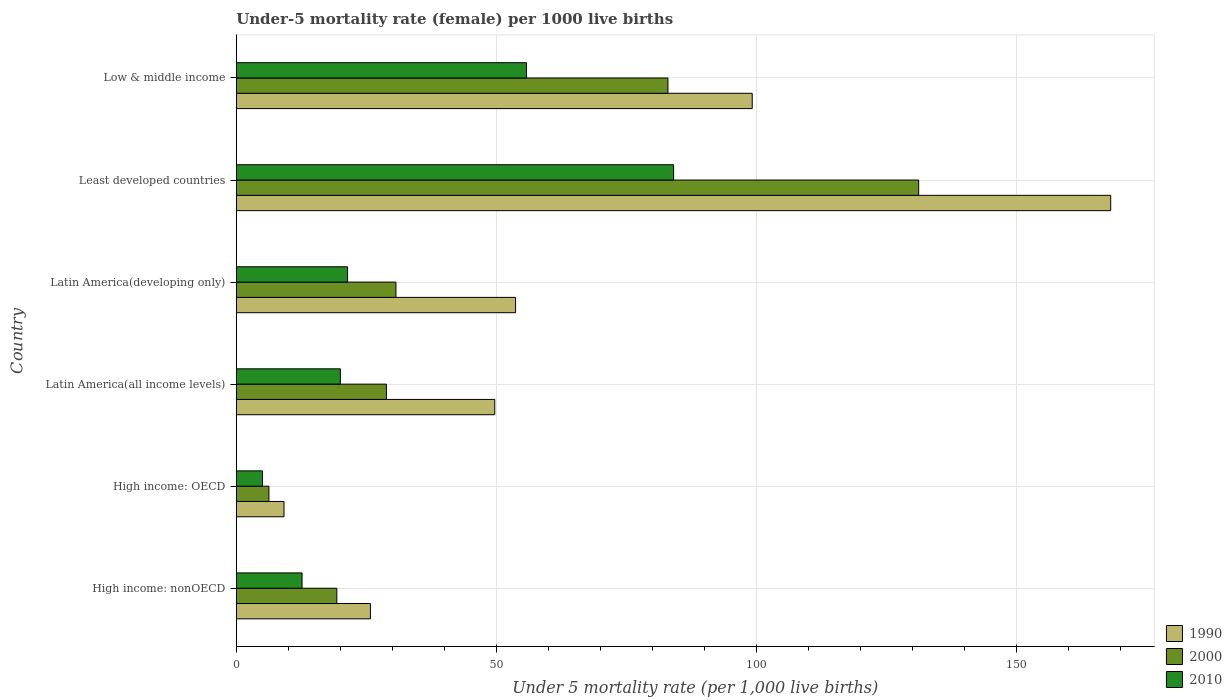How many different coloured bars are there?
Offer a terse response. 3. What is the label of the 6th group of bars from the top?
Give a very brief answer. High income: nonOECD. In how many cases, is the number of bars for a given country not equal to the number of legend labels?
Provide a succinct answer. 0. What is the under-five mortality rate in 1990 in Least developed countries?
Make the answer very short. 168.12. Across all countries, what is the maximum under-five mortality rate in 1990?
Provide a short and direct response. 168.12. Across all countries, what is the minimum under-five mortality rate in 1990?
Provide a short and direct response. 9.18. In which country was the under-five mortality rate in 2000 maximum?
Ensure brevity in your answer.  Least developed countries. In which country was the under-five mortality rate in 2000 minimum?
Provide a short and direct response. High income: OECD. What is the total under-five mortality rate in 2010 in the graph?
Make the answer very short. 198.99. What is the difference between the under-five mortality rate in 2010 in Latin America(developing only) and that in Least developed countries?
Keep it short and to the point. -62.69. What is the difference between the under-five mortality rate in 2000 in Latin America(all income levels) and the under-five mortality rate in 1990 in Least developed countries?
Provide a succinct answer. -139.26. What is the average under-five mortality rate in 2010 per country?
Your response must be concise. 33.17. What is the difference between the under-five mortality rate in 2010 and under-five mortality rate in 1990 in Low & middle income?
Provide a short and direct response. -43.4. What is the ratio of the under-five mortality rate in 2000 in Latin America(all income levels) to that in Low & middle income?
Offer a terse response. 0.35. What is the difference between the highest and the second highest under-five mortality rate in 1990?
Ensure brevity in your answer.  68.92. What is the difference between the highest and the lowest under-five mortality rate in 2000?
Your answer should be very brief. 124.92. In how many countries, is the under-five mortality rate in 2010 greater than the average under-five mortality rate in 2010 taken over all countries?
Your answer should be very brief. 2. Are all the bars in the graph horizontal?
Offer a very short reply. Yes. How many countries are there in the graph?
Offer a very short reply. 6. Are the values on the major ticks of X-axis written in scientific E-notation?
Provide a succinct answer. No. Does the graph contain any zero values?
Your answer should be very brief. No. Does the graph contain grids?
Your answer should be compact. Yes. What is the title of the graph?
Your answer should be compact. Under-5 mortality rate (female) per 1000 live births. What is the label or title of the X-axis?
Your response must be concise. Under 5 mortality rate (per 1,0 live births). What is the Under 5 mortality rate (per 1,000 live births) in 1990 in High income: nonOECD?
Make the answer very short. 25.8. What is the Under 5 mortality rate (per 1,000 live births) in 2000 in High income: nonOECD?
Offer a very short reply. 19.34. What is the Under 5 mortality rate (per 1,000 live births) in 2010 in High income: nonOECD?
Keep it short and to the point. 12.65. What is the Under 5 mortality rate (per 1,000 live births) in 1990 in High income: OECD?
Your response must be concise. 9.18. What is the Under 5 mortality rate (per 1,000 live births) in 2000 in High income: OECD?
Provide a succinct answer. 6.28. What is the Under 5 mortality rate (per 1,000 live births) of 2010 in High income: OECD?
Keep it short and to the point. 5.04. What is the Under 5 mortality rate (per 1,000 live births) of 1990 in Latin America(all income levels)?
Your answer should be compact. 49.7. What is the Under 5 mortality rate (per 1,000 live births) of 2000 in Latin America(all income levels)?
Ensure brevity in your answer.  28.87. What is the Under 5 mortality rate (per 1,000 live births) of 2010 in Latin America(all income levels)?
Ensure brevity in your answer.  20.02. What is the Under 5 mortality rate (per 1,000 live births) of 1990 in Latin America(developing only)?
Provide a succinct answer. 53.7. What is the Under 5 mortality rate (per 1,000 live births) of 2000 in Latin America(developing only)?
Offer a terse response. 30.7. What is the Under 5 mortality rate (per 1,000 live births) of 2010 in Latin America(developing only)?
Offer a terse response. 21.4. What is the Under 5 mortality rate (per 1,000 live births) of 1990 in Least developed countries?
Provide a short and direct response. 168.12. What is the Under 5 mortality rate (per 1,000 live births) in 2000 in Least developed countries?
Ensure brevity in your answer.  131.2. What is the Under 5 mortality rate (per 1,000 live births) of 2010 in Least developed countries?
Offer a terse response. 84.09. What is the Under 5 mortality rate (per 1,000 live births) in 1990 in Low & middle income?
Provide a succinct answer. 99.2. What is the Under 5 mortality rate (per 1,000 live births) of 2000 in Low & middle income?
Ensure brevity in your answer.  83. What is the Under 5 mortality rate (per 1,000 live births) in 2010 in Low & middle income?
Give a very brief answer. 55.8. Across all countries, what is the maximum Under 5 mortality rate (per 1,000 live births) of 1990?
Your response must be concise. 168.12. Across all countries, what is the maximum Under 5 mortality rate (per 1,000 live births) of 2000?
Keep it short and to the point. 131.2. Across all countries, what is the maximum Under 5 mortality rate (per 1,000 live births) in 2010?
Offer a terse response. 84.09. Across all countries, what is the minimum Under 5 mortality rate (per 1,000 live births) of 1990?
Your response must be concise. 9.18. Across all countries, what is the minimum Under 5 mortality rate (per 1,000 live births) in 2000?
Make the answer very short. 6.28. Across all countries, what is the minimum Under 5 mortality rate (per 1,000 live births) in 2010?
Provide a succinct answer. 5.04. What is the total Under 5 mortality rate (per 1,000 live births) in 1990 in the graph?
Your answer should be compact. 405.7. What is the total Under 5 mortality rate (per 1,000 live births) of 2000 in the graph?
Ensure brevity in your answer.  299.39. What is the total Under 5 mortality rate (per 1,000 live births) of 2010 in the graph?
Make the answer very short. 198.99. What is the difference between the Under 5 mortality rate (per 1,000 live births) of 1990 in High income: nonOECD and that in High income: OECD?
Your answer should be compact. 16.61. What is the difference between the Under 5 mortality rate (per 1,000 live births) in 2000 in High income: nonOECD and that in High income: OECD?
Offer a terse response. 13.05. What is the difference between the Under 5 mortality rate (per 1,000 live births) in 2010 in High income: nonOECD and that in High income: OECD?
Your answer should be compact. 7.61. What is the difference between the Under 5 mortality rate (per 1,000 live births) in 1990 in High income: nonOECD and that in Latin America(all income levels)?
Your response must be concise. -23.9. What is the difference between the Under 5 mortality rate (per 1,000 live births) of 2000 in High income: nonOECD and that in Latin America(all income levels)?
Your response must be concise. -9.53. What is the difference between the Under 5 mortality rate (per 1,000 live births) in 2010 in High income: nonOECD and that in Latin America(all income levels)?
Provide a short and direct response. -7.37. What is the difference between the Under 5 mortality rate (per 1,000 live births) in 1990 in High income: nonOECD and that in Latin America(developing only)?
Offer a very short reply. -27.9. What is the difference between the Under 5 mortality rate (per 1,000 live births) in 2000 in High income: nonOECD and that in Latin America(developing only)?
Make the answer very short. -11.36. What is the difference between the Under 5 mortality rate (per 1,000 live births) in 2010 in High income: nonOECD and that in Latin America(developing only)?
Keep it short and to the point. -8.75. What is the difference between the Under 5 mortality rate (per 1,000 live births) of 1990 in High income: nonOECD and that in Least developed countries?
Ensure brevity in your answer.  -142.33. What is the difference between the Under 5 mortality rate (per 1,000 live births) of 2000 in High income: nonOECD and that in Least developed countries?
Your answer should be very brief. -111.87. What is the difference between the Under 5 mortality rate (per 1,000 live births) in 2010 in High income: nonOECD and that in Least developed countries?
Provide a short and direct response. -71.44. What is the difference between the Under 5 mortality rate (per 1,000 live births) in 1990 in High income: nonOECD and that in Low & middle income?
Your response must be concise. -73.4. What is the difference between the Under 5 mortality rate (per 1,000 live births) in 2000 in High income: nonOECD and that in Low & middle income?
Make the answer very short. -63.66. What is the difference between the Under 5 mortality rate (per 1,000 live births) of 2010 in High income: nonOECD and that in Low & middle income?
Make the answer very short. -43.15. What is the difference between the Under 5 mortality rate (per 1,000 live births) of 1990 in High income: OECD and that in Latin America(all income levels)?
Offer a terse response. -40.52. What is the difference between the Under 5 mortality rate (per 1,000 live births) of 2000 in High income: OECD and that in Latin America(all income levels)?
Keep it short and to the point. -22.59. What is the difference between the Under 5 mortality rate (per 1,000 live births) in 2010 in High income: OECD and that in Latin America(all income levels)?
Keep it short and to the point. -14.98. What is the difference between the Under 5 mortality rate (per 1,000 live births) of 1990 in High income: OECD and that in Latin America(developing only)?
Offer a very short reply. -44.52. What is the difference between the Under 5 mortality rate (per 1,000 live births) in 2000 in High income: OECD and that in Latin America(developing only)?
Provide a succinct answer. -24.42. What is the difference between the Under 5 mortality rate (per 1,000 live births) in 2010 in High income: OECD and that in Latin America(developing only)?
Provide a succinct answer. -16.36. What is the difference between the Under 5 mortality rate (per 1,000 live births) of 1990 in High income: OECD and that in Least developed countries?
Offer a terse response. -158.94. What is the difference between the Under 5 mortality rate (per 1,000 live births) in 2000 in High income: OECD and that in Least developed countries?
Keep it short and to the point. -124.92. What is the difference between the Under 5 mortality rate (per 1,000 live births) in 2010 in High income: OECD and that in Least developed countries?
Provide a succinct answer. -79.05. What is the difference between the Under 5 mortality rate (per 1,000 live births) in 1990 in High income: OECD and that in Low & middle income?
Offer a very short reply. -90.02. What is the difference between the Under 5 mortality rate (per 1,000 live births) in 2000 in High income: OECD and that in Low & middle income?
Give a very brief answer. -76.72. What is the difference between the Under 5 mortality rate (per 1,000 live births) of 2010 in High income: OECD and that in Low & middle income?
Provide a short and direct response. -50.76. What is the difference between the Under 5 mortality rate (per 1,000 live births) of 1990 in Latin America(all income levels) and that in Latin America(developing only)?
Give a very brief answer. -4. What is the difference between the Under 5 mortality rate (per 1,000 live births) in 2000 in Latin America(all income levels) and that in Latin America(developing only)?
Provide a succinct answer. -1.83. What is the difference between the Under 5 mortality rate (per 1,000 live births) of 2010 in Latin America(all income levels) and that in Latin America(developing only)?
Offer a terse response. -1.38. What is the difference between the Under 5 mortality rate (per 1,000 live births) of 1990 in Latin America(all income levels) and that in Least developed countries?
Provide a succinct answer. -118.42. What is the difference between the Under 5 mortality rate (per 1,000 live births) in 2000 in Latin America(all income levels) and that in Least developed countries?
Make the answer very short. -102.34. What is the difference between the Under 5 mortality rate (per 1,000 live births) of 2010 in Latin America(all income levels) and that in Least developed countries?
Your answer should be very brief. -64.07. What is the difference between the Under 5 mortality rate (per 1,000 live births) of 1990 in Latin America(all income levels) and that in Low & middle income?
Provide a short and direct response. -49.5. What is the difference between the Under 5 mortality rate (per 1,000 live births) in 2000 in Latin America(all income levels) and that in Low & middle income?
Your answer should be compact. -54.13. What is the difference between the Under 5 mortality rate (per 1,000 live births) of 2010 in Latin America(all income levels) and that in Low & middle income?
Keep it short and to the point. -35.78. What is the difference between the Under 5 mortality rate (per 1,000 live births) in 1990 in Latin America(developing only) and that in Least developed countries?
Keep it short and to the point. -114.42. What is the difference between the Under 5 mortality rate (per 1,000 live births) of 2000 in Latin America(developing only) and that in Least developed countries?
Ensure brevity in your answer.  -100.5. What is the difference between the Under 5 mortality rate (per 1,000 live births) of 2010 in Latin America(developing only) and that in Least developed countries?
Your response must be concise. -62.69. What is the difference between the Under 5 mortality rate (per 1,000 live births) of 1990 in Latin America(developing only) and that in Low & middle income?
Provide a succinct answer. -45.5. What is the difference between the Under 5 mortality rate (per 1,000 live births) of 2000 in Latin America(developing only) and that in Low & middle income?
Keep it short and to the point. -52.3. What is the difference between the Under 5 mortality rate (per 1,000 live births) in 2010 in Latin America(developing only) and that in Low & middle income?
Your answer should be compact. -34.4. What is the difference between the Under 5 mortality rate (per 1,000 live births) of 1990 in Least developed countries and that in Low & middle income?
Your response must be concise. 68.92. What is the difference between the Under 5 mortality rate (per 1,000 live births) of 2000 in Least developed countries and that in Low & middle income?
Offer a terse response. 48.2. What is the difference between the Under 5 mortality rate (per 1,000 live births) of 2010 in Least developed countries and that in Low & middle income?
Your answer should be compact. 28.29. What is the difference between the Under 5 mortality rate (per 1,000 live births) of 1990 in High income: nonOECD and the Under 5 mortality rate (per 1,000 live births) of 2000 in High income: OECD?
Keep it short and to the point. 19.52. What is the difference between the Under 5 mortality rate (per 1,000 live births) in 1990 in High income: nonOECD and the Under 5 mortality rate (per 1,000 live births) in 2010 in High income: OECD?
Offer a very short reply. 20.76. What is the difference between the Under 5 mortality rate (per 1,000 live births) in 2000 in High income: nonOECD and the Under 5 mortality rate (per 1,000 live births) in 2010 in High income: OECD?
Make the answer very short. 14.3. What is the difference between the Under 5 mortality rate (per 1,000 live births) of 1990 in High income: nonOECD and the Under 5 mortality rate (per 1,000 live births) of 2000 in Latin America(all income levels)?
Give a very brief answer. -3.07. What is the difference between the Under 5 mortality rate (per 1,000 live births) in 1990 in High income: nonOECD and the Under 5 mortality rate (per 1,000 live births) in 2010 in Latin America(all income levels)?
Your answer should be very brief. 5.78. What is the difference between the Under 5 mortality rate (per 1,000 live births) of 2000 in High income: nonOECD and the Under 5 mortality rate (per 1,000 live births) of 2010 in Latin America(all income levels)?
Make the answer very short. -0.68. What is the difference between the Under 5 mortality rate (per 1,000 live births) of 1990 in High income: nonOECD and the Under 5 mortality rate (per 1,000 live births) of 2000 in Latin America(developing only)?
Provide a succinct answer. -4.9. What is the difference between the Under 5 mortality rate (per 1,000 live births) in 1990 in High income: nonOECD and the Under 5 mortality rate (per 1,000 live births) in 2010 in Latin America(developing only)?
Provide a short and direct response. 4.4. What is the difference between the Under 5 mortality rate (per 1,000 live births) of 2000 in High income: nonOECD and the Under 5 mortality rate (per 1,000 live births) of 2010 in Latin America(developing only)?
Keep it short and to the point. -2.06. What is the difference between the Under 5 mortality rate (per 1,000 live births) of 1990 in High income: nonOECD and the Under 5 mortality rate (per 1,000 live births) of 2000 in Least developed countries?
Offer a terse response. -105.41. What is the difference between the Under 5 mortality rate (per 1,000 live births) in 1990 in High income: nonOECD and the Under 5 mortality rate (per 1,000 live births) in 2010 in Least developed countries?
Offer a very short reply. -58.29. What is the difference between the Under 5 mortality rate (per 1,000 live births) of 2000 in High income: nonOECD and the Under 5 mortality rate (per 1,000 live births) of 2010 in Least developed countries?
Provide a short and direct response. -64.75. What is the difference between the Under 5 mortality rate (per 1,000 live births) of 1990 in High income: nonOECD and the Under 5 mortality rate (per 1,000 live births) of 2000 in Low & middle income?
Offer a terse response. -57.2. What is the difference between the Under 5 mortality rate (per 1,000 live births) of 1990 in High income: nonOECD and the Under 5 mortality rate (per 1,000 live births) of 2010 in Low & middle income?
Make the answer very short. -30. What is the difference between the Under 5 mortality rate (per 1,000 live births) in 2000 in High income: nonOECD and the Under 5 mortality rate (per 1,000 live births) in 2010 in Low & middle income?
Your response must be concise. -36.46. What is the difference between the Under 5 mortality rate (per 1,000 live births) of 1990 in High income: OECD and the Under 5 mortality rate (per 1,000 live births) of 2000 in Latin America(all income levels)?
Provide a succinct answer. -19.68. What is the difference between the Under 5 mortality rate (per 1,000 live births) in 1990 in High income: OECD and the Under 5 mortality rate (per 1,000 live births) in 2010 in Latin America(all income levels)?
Provide a short and direct response. -10.83. What is the difference between the Under 5 mortality rate (per 1,000 live births) in 2000 in High income: OECD and the Under 5 mortality rate (per 1,000 live births) in 2010 in Latin America(all income levels)?
Provide a succinct answer. -13.74. What is the difference between the Under 5 mortality rate (per 1,000 live births) in 1990 in High income: OECD and the Under 5 mortality rate (per 1,000 live births) in 2000 in Latin America(developing only)?
Make the answer very short. -21.52. What is the difference between the Under 5 mortality rate (per 1,000 live births) in 1990 in High income: OECD and the Under 5 mortality rate (per 1,000 live births) in 2010 in Latin America(developing only)?
Offer a terse response. -12.22. What is the difference between the Under 5 mortality rate (per 1,000 live births) of 2000 in High income: OECD and the Under 5 mortality rate (per 1,000 live births) of 2010 in Latin America(developing only)?
Provide a succinct answer. -15.12. What is the difference between the Under 5 mortality rate (per 1,000 live births) of 1990 in High income: OECD and the Under 5 mortality rate (per 1,000 live births) of 2000 in Least developed countries?
Your response must be concise. -122.02. What is the difference between the Under 5 mortality rate (per 1,000 live births) of 1990 in High income: OECD and the Under 5 mortality rate (per 1,000 live births) of 2010 in Least developed countries?
Offer a very short reply. -74.9. What is the difference between the Under 5 mortality rate (per 1,000 live births) in 2000 in High income: OECD and the Under 5 mortality rate (per 1,000 live births) in 2010 in Least developed countries?
Provide a short and direct response. -77.81. What is the difference between the Under 5 mortality rate (per 1,000 live births) in 1990 in High income: OECD and the Under 5 mortality rate (per 1,000 live births) in 2000 in Low & middle income?
Your response must be concise. -73.82. What is the difference between the Under 5 mortality rate (per 1,000 live births) of 1990 in High income: OECD and the Under 5 mortality rate (per 1,000 live births) of 2010 in Low & middle income?
Give a very brief answer. -46.62. What is the difference between the Under 5 mortality rate (per 1,000 live births) of 2000 in High income: OECD and the Under 5 mortality rate (per 1,000 live births) of 2010 in Low & middle income?
Provide a short and direct response. -49.52. What is the difference between the Under 5 mortality rate (per 1,000 live births) of 1990 in Latin America(all income levels) and the Under 5 mortality rate (per 1,000 live births) of 2000 in Latin America(developing only)?
Offer a very short reply. 19. What is the difference between the Under 5 mortality rate (per 1,000 live births) of 1990 in Latin America(all income levels) and the Under 5 mortality rate (per 1,000 live births) of 2010 in Latin America(developing only)?
Offer a terse response. 28.3. What is the difference between the Under 5 mortality rate (per 1,000 live births) in 2000 in Latin America(all income levels) and the Under 5 mortality rate (per 1,000 live births) in 2010 in Latin America(developing only)?
Provide a succinct answer. 7.47. What is the difference between the Under 5 mortality rate (per 1,000 live births) in 1990 in Latin America(all income levels) and the Under 5 mortality rate (per 1,000 live births) in 2000 in Least developed countries?
Offer a terse response. -81.5. What is the difference between the Under 5 mortality rate (per 1,000 live births) of 1990 in Latin America(all income levels) and the Under 5 mortality rate (per 1,000 live births) of 2010 in Least developed countries?
Your response must be concise. -34.39. What is the difference between the Under 5 mortality rate (per 1,000 live births) of 2000 in Latin America(all income levels) and the Under 5 mortality rate (per 1,000 live births) of 2010 in Least developed countries?
Provide a succinct answer. -55.22. What is the difference between the Under 5 mortality rate (per 1,000 live births) in 1990 in Latin America(all income levels) and the Under 5 mortality rate (per 1,000 live births) in 2000 in Low & middle income?
Provide a succinct answer. -33.3. What is the difference between the Under 5 mortality rate (per 1,000 live births) of 1990 in Latin America(all income levels) and the Under 5 mortality rate (per 1,000 live births) of 2010 in Low & middle income?
Your answer should be compact. -6.1. What is the difference between the Under 5 mortality rate (per 1,000 live births) in 2000 in Latin America(all income levels) and the Under 5 mortality rate (per 1,000 live births) in 2010 in Low & middle income?
Ensure brevity in your answer.  -26.93. What is the difference between the Under 5 mortality rate (per 1,000 live births) of 1990 in Latin America(developing only) and the Under 5 mortality rate (per 1,000 live births) of 2000 in Least developed countries?
Make the answer very short. -77.5. What is the difference between the Under 5 mortality rate (per 1,000 live births) in 1990 in Latin America(developing only) and the Under 5 mortality rate (per 1,000 live births) in 2010 in Least developed countries?
Your response must be concise. -30.39. What is the difference between the Under 5 mortality rate (per 1,000 live births) in 2000 in Latin America(developing only) and the Under 5 mortality rate (per 1,000 live births) in 2010 in Least developed countries?
Make the answer very short. -53.39. What is the difference between the Under 5 mortality rate (per 1,000 live births) in 1990 in Latin America(developing only) and the Under 5 mortality rate (per 1,000 live births) in 2000 in Low & middle income?
Your answer should be very brief. -29.3. What is the difference between the Under 5 mortality rate (per 1,000 live births) in 2000 in Latin America(developing only) and the Under 5 mortality rate (per 1,000 live births) in 2010 in Low & middle income?
Ensure brevity in your answer.  -25.1. What is the difference between the Under 5 mortality rate (per 1,000 live births) in 1990 in Least developed countries and the Under 5 mortality rate (per 1,000 live births) in 2000 in Low & middle income?
Offer a very short reply. 85.12. What is the difference between the Under 5 mortality rate (per 1,000 live births) of 1990 in Least developed countries and the Under 5 mortality rate (per 1,000 live births) of 2010 in Low & middle income?
Offer a terse response. 112.32. What is the difference between the Under 5 mortality rate (per 1,000 live births) of 2000 in Least developed countries and the Under 5 mortality rate (per 1,000 live births) of 2010 in Low & middle income?
Provide a short and direct response. 75.4. What is the average Under 5 mortality rate (per 1,000 live births) of 1990 per country?
Your response must be concise. 67.62. What is the average Under 5 mortality rate (per 1,000 live births) of 2000 per country?
Ensure brevity in your answer.  49.9. What is the average Under 5 mortality rate (per 1,000 live births) in 2010 per country?
Your answer should be compact. 33.17. What is the difference between the Under 5 mortality rate (per 1,000 live births) in 1990 and Under 5 mortality rate (per 1,000 live births) in 2000 in High income: nonOECD?
Ensure brevity in your answer.  6.46. What is the difference between the Under 5 mortality rate (per 1,000 live births) of 1990 and Under 5 mortality rate (per 1,000 live births) of 2010 in High income: nonOECD?
Your response must be concise. 13.15. What is the difference between the Under 5 mortality rate (per 1,000 live births) in 2000 and Under 5 mortality rate (per 1,000 live births) in 2010 in High income: nonOECD?
Provide a succinct answer. 6.69. What is the difference between the Under 5 mortality rate (per 1,000 live births) of 1990 and Under 5 mortality rate (per 1,000 live births) of 2000 in High income: OECD?
Your answer should be compact. 2.9. What is the difference between the Under 5 mortality rate (per 1,000 live births) of 1990 and Under 5 mortality rate (per 1,000 live births) of 2010 in High income: OECD?
Your answer should be compact. 4.14. What is the difference between the Under 5 mortality rate (per 1,000 live births) in 2000 and Under 5 mortality rate (per 1,000 live births) in 2010 in High income: OECD?
Your response must be concise. 1.24. What is the difference between the Under 5 mortality rate (per 1,000 live births) in 1990 and Under 5 mortality rate (per 1,000 live births) in 2000 in Latin America(all income levels)?
Your response must be concise. 20.83. What is the difference between the Under 5 mortality rate (per 1,000 live births) in 1990 and Under 5 mortality rate (per 1,000 live births) in 2010 in Latin America(all income levels)?
Ensure brevity in your answer.  29.68. What is the difference between the Under 5 mortality rate (per 1,000 live births) of 2000 and Under 5 mortality rate (per 1,000 live births) of 2010 in Latin America(all income levels)?
Offer a very short reply. 8.85. What is the difference between the Under 5 mortality rate (per 1,000 live births) in 1990 and Under 5 mortality rate (per 1,000 live births) in 2000 in Latin America(developing only)?
Ensure brevity in your answer.  23. What is the difference between the Under 5 mortality rate (per 1,000 live births) of 1990 and Under 5 mortality rate (per 1,000 live births) of 2010 in Latin America(developing only)?
Your answer should be very brief. 32.3. What is the difference between the Under 5 mortality rate (per 1,000 live births) in 2000 and Under 5 mortality rate (per 1,000 live births) in 2010 in Latin America(developing only)?
Offer a very short reply. 9.3. What is the difference between the Under 5 mortality rate (per 1,000 live births) of 1990 and Under 5 mortality rate (per 1,000 live births) of 2000 in Least developed countries?
Provide a short and direct response. 36.92. What is the difference between the Under 5 mortality rate (per 1,000 live births) of 1990 and Under 5 mortality rate (per 1,000 live births) of 2010 in Least developed countries?
Keep it short and to the point. 84.04. What is the difference between the Under 5 mortality rate (per 1,000 live births) of 2000 and Under 5 mortality rate (per 1,000 live births) of 2010 in Least developed countries?
Give a very brief answer. 47.12. What is the difference between the Under 5 mortality rate (per 1,000 live births) of 1990 and Under 5 mortality rate (per 1,000 live births) of 2010 in Low & middle income?
Your answer should be very brief. 43.4. What is the difference between the Under 5 mortality rate (per 1,000 live births) in 2000 and Under 5 mortality rate (per 1,000 live births) in 2010 in Low & middle income?
Keep it short and to the point. 27.2. What is the ratio of the Under 5 mortality rate (per 1,000 live births) of 1990 in High income: nonOECD to that in High income: OECD?
Your answer should be compact. 2.81. What is the ratio of the Under 5 mortality rate (per 1,000 live births) in 2000 in High income: nonOECD to that in High income: OECD?
Provide a succinct answer. 3.08. What is the ratio of the Under 5 mortality rate (per 1,000 live births) in 2010 in High income: nonOECD to that in High income: OECD?
Your answer should be very brief. 2.51. What is the ratio of the Under 5 mortality rate (per 1,000 live births) of 1990 in High income: nonOECD to that in Latin America(all income levels)?
Make the answer very short. 0.52. What is the ratio of the Under 5 mortality rate (per 1,000 live births) in 2000 in High income: nonOECD to that in Latin America(all income levels)?
Make the answer very short. 0.67. What is the ratio of the Under 5 mortality rate (per 1,000 live births) of 2010 in High income: nonOECD to that in Latin America(all income levels)?
Your answer should be compact. 0.63. What is the ratio of the Under 5 mortality rate (per 1,000 live births) of 1990 in High income: nonOECD to that in Latin America(developing only)?
Give a very brief answer. 0.48. What is the ratio of the Under 5 mortality rate (per 1,000 live births) in 2000 in High income: nonOECD to that in Latin America(developing only)?
Ensure brevity in your answer.  0.63. What is the ratio of the Under 5 mortality rate (per 1,000 live births) of 2010 in High income: nonOECD to that in Latin America(developing only)?
Provide a short and direct response. 0.59. What is the ratio of the Under 5 mortality rate (per 1,000 live births) in 1990 in High income: nonOECD to that in Least developed countries?
Offer a terse response. 0.15. What is the ratio of the Under 5 mortality rate (per 1,000 live births) in 2000 in High income: nonOECD to that in Least developed countries?
Give a very brief answer. 0.15. What is the ratio of the Under 5 mortality rate (per 1,000 live births) in 2010 in High income: nonOECD to that in Least developed countries?
Keep it short and to the point. 0.15. What is the ratio of the Under 5 mortality rate (per 1,000 live births) in 1990 in High income: nonOECD to that in Low & middle income?
Keep it short and to the point. 0.26. What is the ratio of the Under 5 mortality rate (per 1,000 live births) in 2000 in High income: nonOECD to that in Low & middle income?
Keep it short and to the point. 0.23. What is the ratio of the Under 5 mortality rate (per 1,000 live births) in 2010 in High income: nonOECD to that in Low & middle income?
Provide a succinct answer. 0.23. What is the ratio of the Under 5 mortality rate (per 1,000 live births) in 1990 in High income: OECD to that in Latin America(all income levels)?
Provide a short and direct response. 0.18. What is the ratio of the Under 5 mortality rate (per 1,000 live births) of 2000 in High income: OECD to that in Latin America(all income levels)?
Your response must be concise. 0.22. What is the ratio of the Under 5 mortality rate (per 1,000 live births) of 2010 in High income: OECD to that in Latin America(all income levels)?
Keep it short and to the point. 0.25. What is the ratio of the Under 5 mortality rate (per 1,000 live births) of 1990 in High income: OECD to that in Latin America(developing only)?
Offer a very short reply. 0.17. What is the ratio of the Under 5 mortality rate (per 1,000 live births) of 2000 in High income: OECD to that in Latin America(developing only)?
Ensure brevity in your answer.  0.2. What is the ratio of the Under 5 mortality rate (per 1,000 live births) in 2010 in High income: OECD to that in Latin America(developing only)?
Your response must be concise. 0.24. What is the ratio of the Under 5 mortality rate (per 1,000 live births) in 1990 in High income: OECD to that in Least developed countries?
Provide a short and direct response. 0.05. What is the ratio of the Under 5 mortality rate (per 1,000 live births) in 2000 in High income: OECD to that in Least developed countries?
Your answer should be compact. 0.05. What is the ratio of the Under 5 mortality rate (per 1,000 live births) of 2010 in High income: OECD to that in Least developed countries?
Provide a succinct answer. 0.06. What is the ratio of the Under 5 mortality rate (per 1,000 live births) in 1990 in High income: OECD to that in Low & middle income?
Keep it short and to the point. 0.09. What is the ratio of the Under 5 mortality rate (per 1,000 live births) in 2000 in High income: OECD to that in Low & middle income?
Provide a succinct answer. 0.08. What is the ratio of the Under 5 mortality rate (per 1,000 live births) in 2010 in High income: OECD to that in Low & middle income?
Provide a succinct answer. 0.09. What is the ratio of the Under 5 mortality rate (per 1,000 live births) of 1990 in Latin America(all income levels) to that in Latin America(developing only)?
Offer a very short reply. 0.93. What is the ratio of the Under 5 mortality rate (per 1,000 live births) of 2000 in Latin America(all income levels) to that in Latin America(developing only)?
Your answer should be very brief. 0.94. What is the ratio of the Under 5 mortality rate (per 1,000 live births) of 2010 in Latin America(all income levels) to that in Latin America(developing only)?
Ensure brevity in your answer.  0.94. What is the ratio of the Under 5 mortality rate (per 1,000 live births) of 1990 in Latin America(all income levels) to that in Least developed countries?
Provide a succinct answer. 0.3. What is the ratio of the Under 5 mortality rate (per 1,000 live births) in 2000 in Latin America(all income levels) to that in Least developed countries?
Offer a terse response. 0.22. What is the ratio of the Under 5 mortality rate (per 1,000 live births) of 2010 in Latin America(all income levels) to that in Least developed countries?
Keep it short and to the point. 0.24. What is the ratio of the Under 5 mortality rate (per 1,000 live births) in 1990 in Latin America(all income levels) to that in Low & middle income?
Your answer should be compact. 0.5. What is the ratio of the Under 5 mortality rate (per 1,000 live births) of 2000 in Latin America(all income levels) to that in Low & middle income?
Provide a short and direct response. 0.35. What is the ratio of the Under 5 mortality rate (per 1,000 live births) of 2010 in Latin America(all income levels) to that in Low & middle income?
Ensure brevity in your answer.  0.36. What is the ratio of the Under 5 mortality rate (per 1,000 live births) in 1990 in Latin America(developing only) to that in Least developed countries?
Offer a very short reply. 0.32. What is the ratio of the Under 5 mortality rate (per 1,000 live births) in 2000 in Latin America(developing only) to that in Least developed countries?
Your answer should be very brief. 0.23. What is the ratio of the Under 5 mortality rate (per 1,000 live births) of 2010 in Latin America(developing only) to that in Least developed countries?
Offer a very short reply. 0.25. What is the ratio of the Under 5 mortality rate (per 1,000 live births) in 1990 in Latin America(developing only) to that in Low & middle income?
Provide a succinct answer. 0.54. What is the ratio of the Under 5 mortality rate (per 1,000 live births) in 2000 in Latin America(developing only) to that in Low & middle income?
Ensure brevity in your answer.  0.37. What is the ratio of the Under 5 mortality rate (per 1,000 live births) in 2010 in Latin America(developing only) to that in Low & middle income?
Keep it short and to the point. 0.38. What is the ratio of the Under 5 mortality rate (per 1,000 live births) in 1990 in Least developed countries to that in Low & middle income?
Your answer should be very brief. 1.69. What is the ratio of the Under 5 mortality rate (per 1,000 live births) in 2000 in Least developed countries to that in Low & middle income?
Offer a very short reply. 1.58. What is the ratio of the Under 5 mortality rate (per 1,000 live births) in 2010 in Least developed countries to that in Low & middle income?
Provide a succinct answer. 1.51. What is the difference between the highest and the second highest Under 5 mortality rate (per 1,000 live births) in 1990?
Provide a succinct answer. 68.92. What is the difference between the highest and the second highest Under 5 mortality rate (per 1,000 live births) of 2000?
Keep it short and to the point. 48.2. What is the difference between the highest and the second highest Under 5 mortality rate (per 1,000 live births) of 2010?
Ensure brevity in your answer.  28.29. What is the difference between the highest and the lowest Under 5 mortality rate (per 1,000 live births) of 1990?
Keep it short and to the point. 158.94. What is the difference between the highest and the lowest Under 5 mortality rate (per 1,000 live births) in 2000?
Your answer should be compact. 124.92. What is the difference between the highest and the lowest Under 5 mortality rate (per 1,000 live births) of 2010?
Offer a very short reply. 79.05. 